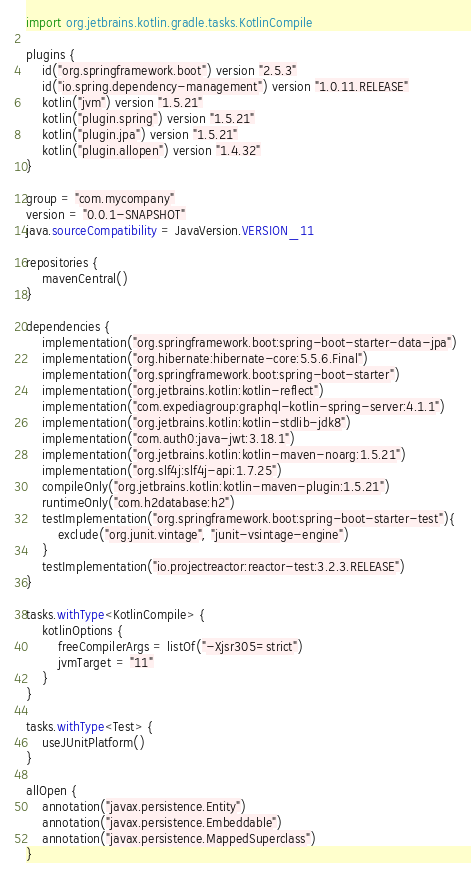Convert code to text. <code><loc_0><loc_0><loc_500><loc_500><_Kotlin_>import org.jetbrains.kotlin.gradle.tasks.KotlinCompile

plugins {
	id("org.springframework.boot") version "2.5.3"
	id("io.spring.dependency-management") version "1.0.11.RELEASE"
	kotlin("jvm") version "1.5.21"
	kotlin("plugin.spring") version "1.5.21"
	kotlin("plugin.jpa") version "1.5.21"
	kotlin("plugin.allopen") version "1.4.32"
}

group = "com.mycompany"
version = "0.0.1-SNAPSHOT"
java.sourceCompatibility = JavaVersion.VERSION_11

repositories {
	mavenCentral()
}

dependencies {
	implementation("org.springframework.boot:spring-boot-starter-data-jpa")
	implementation("org.hibernate:hibernate-core:5.5.6.Final")
	implementation("org.springframework.boot:spring-boot-starter")
	implementation("org.jetbrains.kotlin:kotlin-reflect")
	implementation("com.expediagroup:graphql-kotlin-spring-server:4.1.1")
	implementation("org.jetbrains.kotlin:kotlin-stdlib-jdk8")
	implementation("com.auth0:java-jwt:3.18.1")
	implementation("org.jetbrains.kotlin:kotlin-maven-noarg:1.5.21")
	implementation("org.slf4j:slf4j-api:1.7.25")
	compileOnly("org.jetbrains.kotlin:kotlin-maven-plugin:1.5.21")
	runtimeOnly("com.h2database:h2")
	testImplementation("org.springframework.boot:spring-boot-starter-test"){
		exclude("org.junit.vintage", "junit-vsintage-engine")
	}
	testImplementation("io.projectreactor:reactor-test:3.2.3.RELEASE")
}

tasks.withType<KotlinCompile> {
	kotlinOptions {
		freeCompilerArgs = listOf("-Xjsr305=strict")
		jvmTarget = "11"
	}
}

tasks.withType<Test> {
	useJUnitPlatform()
}

allOpen {
	annotation("javax.persistence.Entity")
	annotation("javax.persistence.Embeddable")
	annotation("javax.persistence.MappedSuperclass")
}</code> 